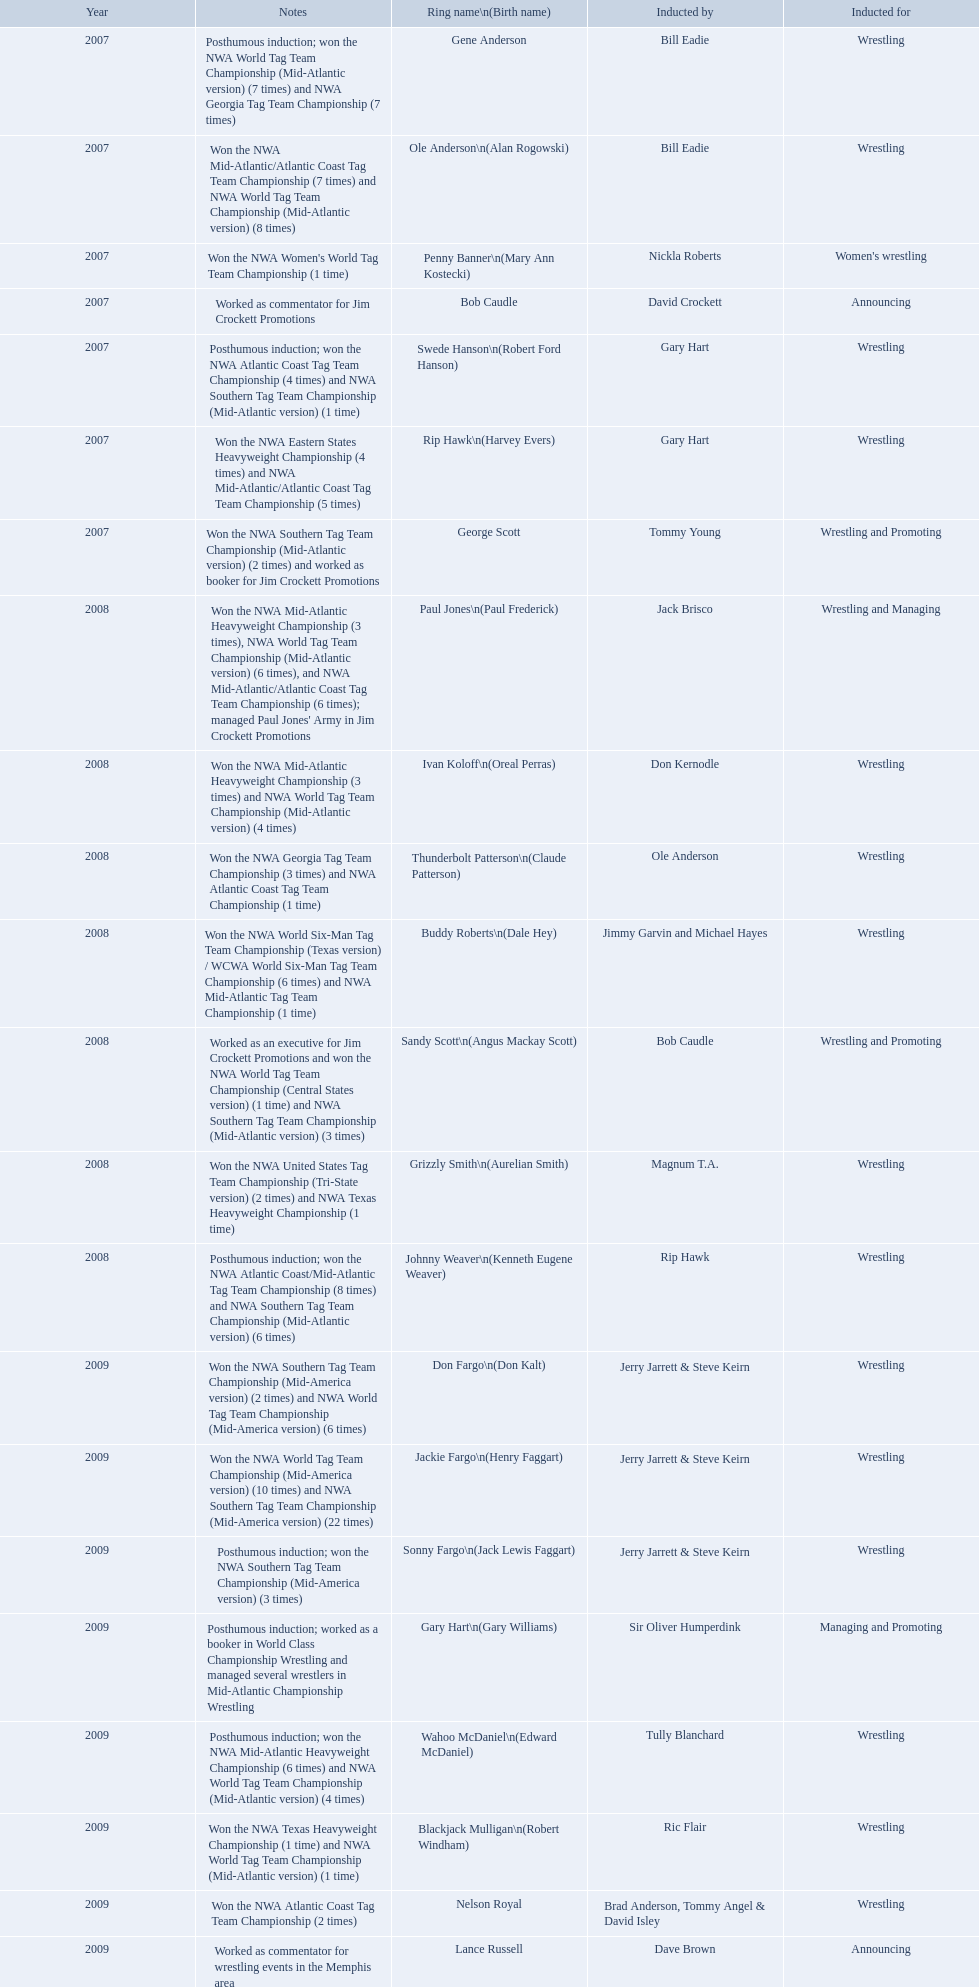What year was the induction held? 2007. Which inductee was not alive? Gene Anderson. 